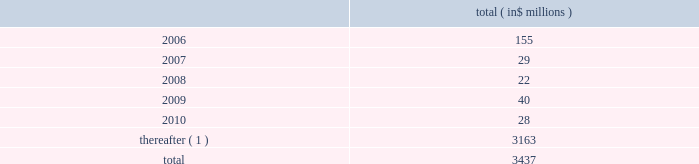Celanese corporation and subsidiaries notes to consolidated financial statements ( continued ) 2022 amend certain material agreements governing bcp crystal 2019s indebtedness ; 2022 change the business conducted by celanese holdings and its subsidiaries ; and 2022 enter into hedging agreements that restrict dividends from subsidiaries .
In addition , the senior credit facilities require bcp crystal to maintain the following financial covenants : a maximum total leverage ratio , a maximum bank debt leverage ratio , a minimum interest coverage ratio and maximum capital expenditures limitation .
The maximum consolidated net bank debt to adjusted ebitda ratio , as defined , previously required under the senior credit facilities , was eliminated when the company amended the facilities in january 2005 .
As of december 31 , 2005 , the company was in compliance with all of the financial covenants related to its debt agreements .
The maturation of the company 2019s debt , including short term borrowings , is as follows : ( in $ millions ) .
( 1 ) includes $ 2 million purchase accounting adjustment to assumed debt .
17 .
Benefit obligations pension obligations .
Pension obligations are established for benefits payable in the form of retirement , disability and surviving dependent pensions .
The benefits offered vary according to the legal , fiscal and economic conditions of each country .
The commitments result from participation in defined contribution and defined benefit plans , primarily in the u.s .
Benefits are dependent on years of service and the employee 2019s compensation .
Supplemental retirement benefits provided to certain employees are non-qualified for u.s .
Tax purposes .
Separate trusts have been established for some non-qualified plans .
Defined benefit pension plans exist at certain locations in north america and europe .
As of december 31 , 2005 , the company 2019s u.s .
Qualified pension plan represented greater than 85% ( 85 % ) and 75% ( 75 % ) of celanese 2019s pension plan assets and liabilities , respectively .
Independent trusts or insurance companies administer the majority of these plans .
Actuarial valuations for these plans are prepared annually .
The company sponsors various defined contribution plans in europe and north america covering certain employees .
Employees may contribute to these plans and the company will match these contributions in varying amounts .
Contributions to the defined contribution plans are based on specified percentages of employee contributions and they aggregated $ 12 million for the year ended decem- ber 31 , 2005 , $ 8 million for the nine months ended december 31 , 2004 , $ 3 million for the three months ended march 31 , 2004 and $ 11 million for the year ended december 31 , 2003 .
In connection with the acquisition of cag , the purchaser agreed to pre-fund $ 463 million of certain pension obligations .
During the nine months ended december 31 , 2004 , $ 409 million was pre-funded to the company 2019s pension plans .
The company contributed an additional $ 54 million to the non-qualified pension plan 2019s rabbi trusts in february 2005 .
In connection with the company 2019s acquisition of vinamul and acetex , the company assumed certain assets and obligations related to the acquired pension plans .
The company recorded liabilities of $ 128 million for these pension plans .
Total pension assets acquired amounted to $ 85 million. .
What portion of the total debt is due within 12 months? 
Computations: (155 / 3437)
Answer: 0.0451. 